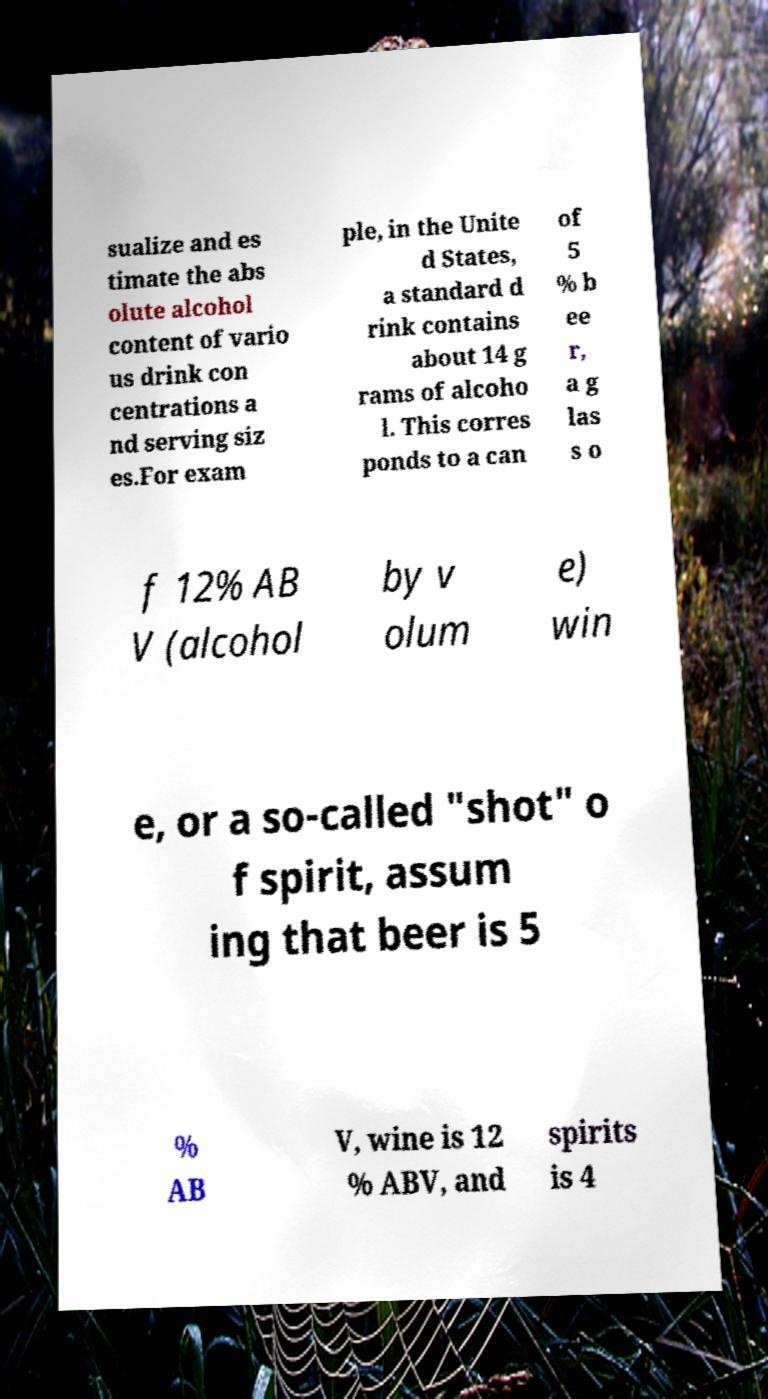Please read and relay the text visible in this image. What does it say? sualize and es timate the abs olute alcohol content of vario us drink con centrations a nd serving siz es.For exam ple, in the Unite d States, a standard d rink contains about 14 g rams of alcoho l. This corres ponds to a can of 5 % b ee r, a g las s o f 12% AB V (alcohol by v olum e) win e, or a so-called "shot" o f spirit, assum ing that beer is 5 % AB V, wine is 12 % ABV, and spirits is 4 